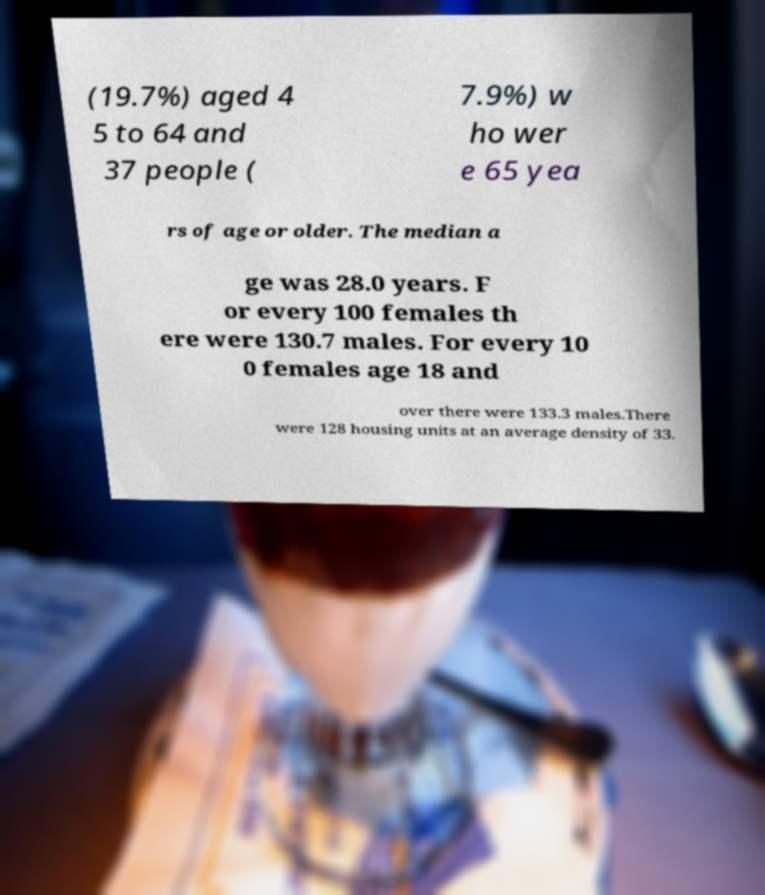Can you read and provide the text displayed in the image?This photo seems to have some interesting text. Can you extract and type it out for me? (19.7%) aged 4 5 to 64 and 37 people ( 7.9%) w ho wer e 65 yea rs of age or older. The median a ge was 28.0 years. F or every 100 females th ere were 130.7 males. For every 10 0 females age 18 and over there were 133.3 males.There were 128 housing units at an average density of 33. 